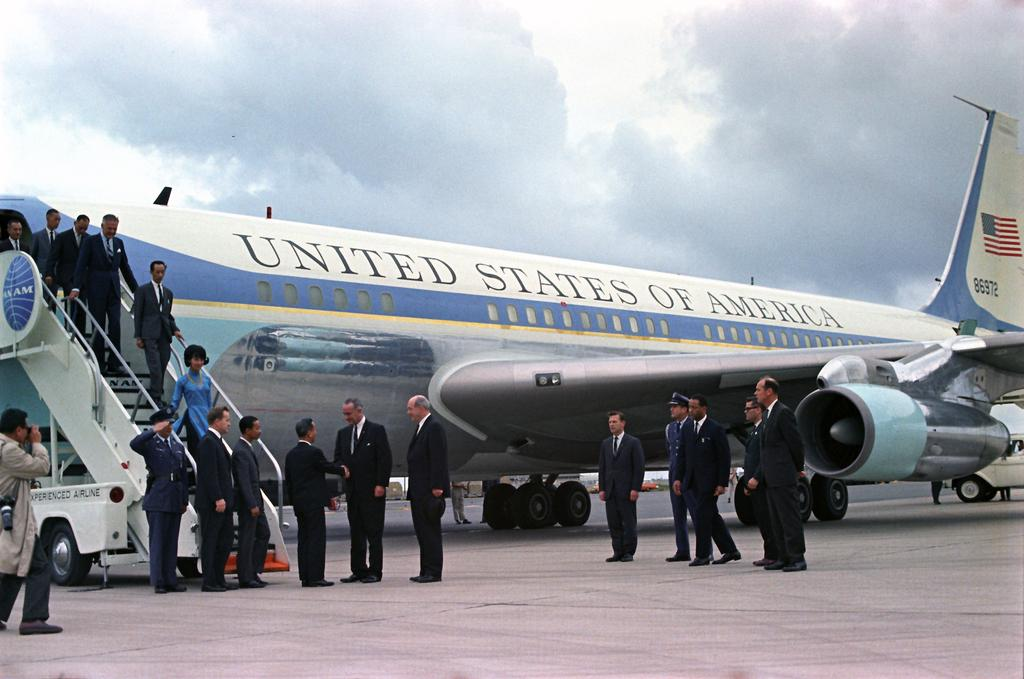<image>
Describe the image concisely. People are getting off a United States of America airplane. 